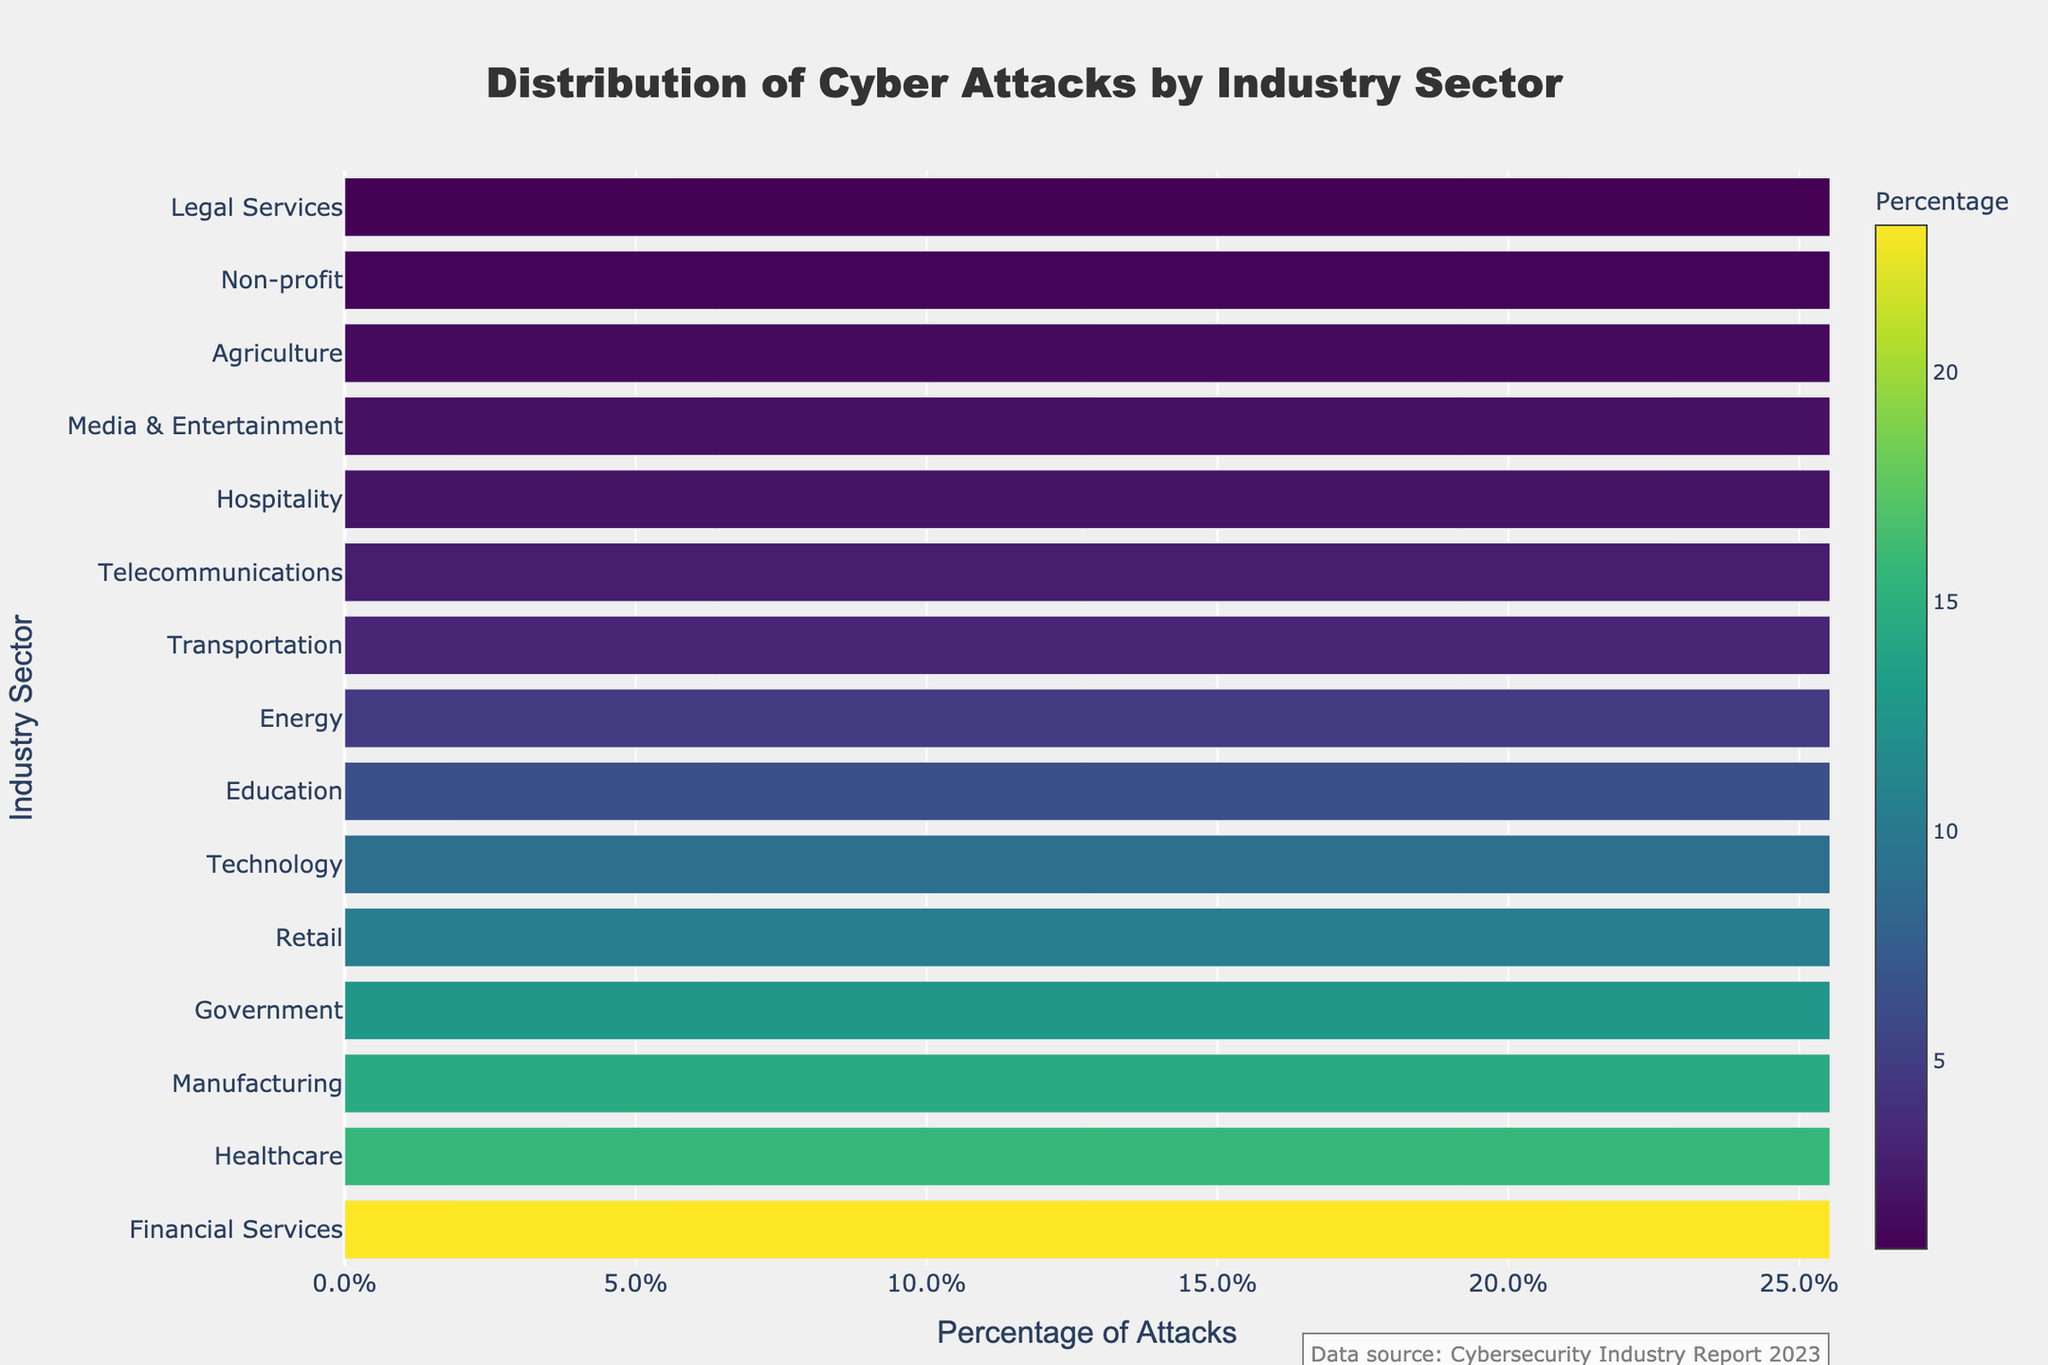What's the industry with the highest percentage of cyber attacks? The bar representing Financial Services is the longest and positioned at the top, indicating it has the highest percentage.
Answer: Financial Services How much higher is the percentage of attacks on Financial Services compared to Healthcare? Financial Services has 23.2% of attacks, while Healthcare has 15.8%. Subtract the percentage of Healthcare from Financial Services: 23.2% - 15.8% = 7.4%
Answer: 7.4% Which two industries have the smallest percentages of cyber attacks? The shortest bars at the bottom represent Non-profit and Legal Services with 1.1% and 0.9% respectively.
Answer: Non-profit, Legal Services What's the combined percentage of cyber attacks targeting the top three industries? The top three industries are Financial Services (23.2%), Healthcare (15.8%), and Manufacturing (14.5%). Add these percentages together: 23.2% + 15.8% + 14.5% = 53.5%
Answer: 53.5% How does the percentage of attacks on the Technology sector compare to the Retail sector? The Technology sector has 8.9%, and the Retail sector has 10.3%. Since 10.3% > 8.9%, Retail has a higher percentage.
Answer: Retail has a higher percentage What’s the difference in the percentage of attacks between the Government and Energy sectors? Government is at 12.7%, and Energy is at 4.8%. Subtract the Energy percentage from Government: 12.7% - 4.8% = 7.9%
Answer: 7.9% Which industry has the smallest percentage of cyber attacks and what is it? The shortest bar indicates Legal Services has the smallest percentage of 0.9%.
Answer: Legal Services, 0.9% Identify all sectors with a percentage of cyber attacks greater than 10%. The bars representing Financial Services (23.2%), Healthcare (15.8%), Manufacturing (14.5%), Government (12.7%), and Retail (10.3%) exceed 10%.
Answer: Financial Services, Healthcare, Manufacturing, Government, Retail Compare the combined percentage of attacks on Education, Energy, and Transportation sectors to the Healthcare sector. Education (6.4%) + Energy (4.8%) + Transportation (3.2%) = 14.4%. Compare this to Healthcare which is 15.8%. Since 15.8% > 14.4%, Healthcare has a higher percentage.
Answer: Healthcare has a higher percentage What’s the average percentage of cyber attacks on Media & Entertainment, Agriculture, and Legal Services? Summing them: Media & Entertainment (1.9%), Agriculture (1.5%), Legal Services (0.9%) = 4.3%. The average is 4.3% / 3 = 1.43%.
Answer: 1.43% 